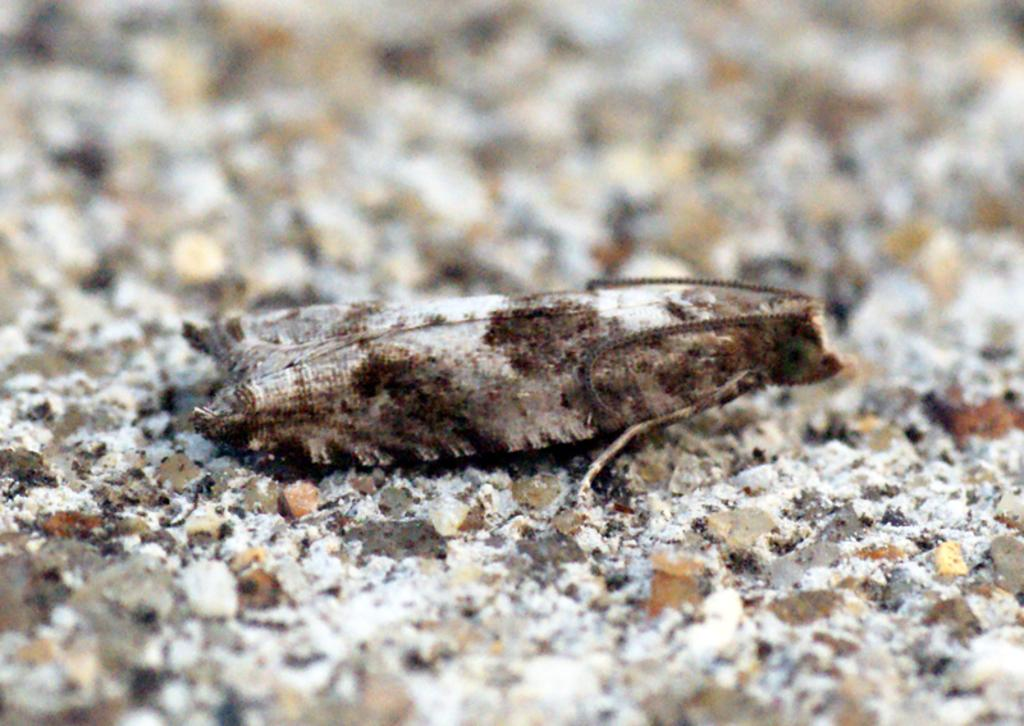What type of creature can be seen in the image? There is an insect present in the image. Where is the insect located in the image? The insect is on the ground. What type of war is being fought in the image? There is no war present in the image; it only features an insect on the ground. Are there any slaves visible in the image? There are no slaves present in the image; it only features an insect on the ground. 